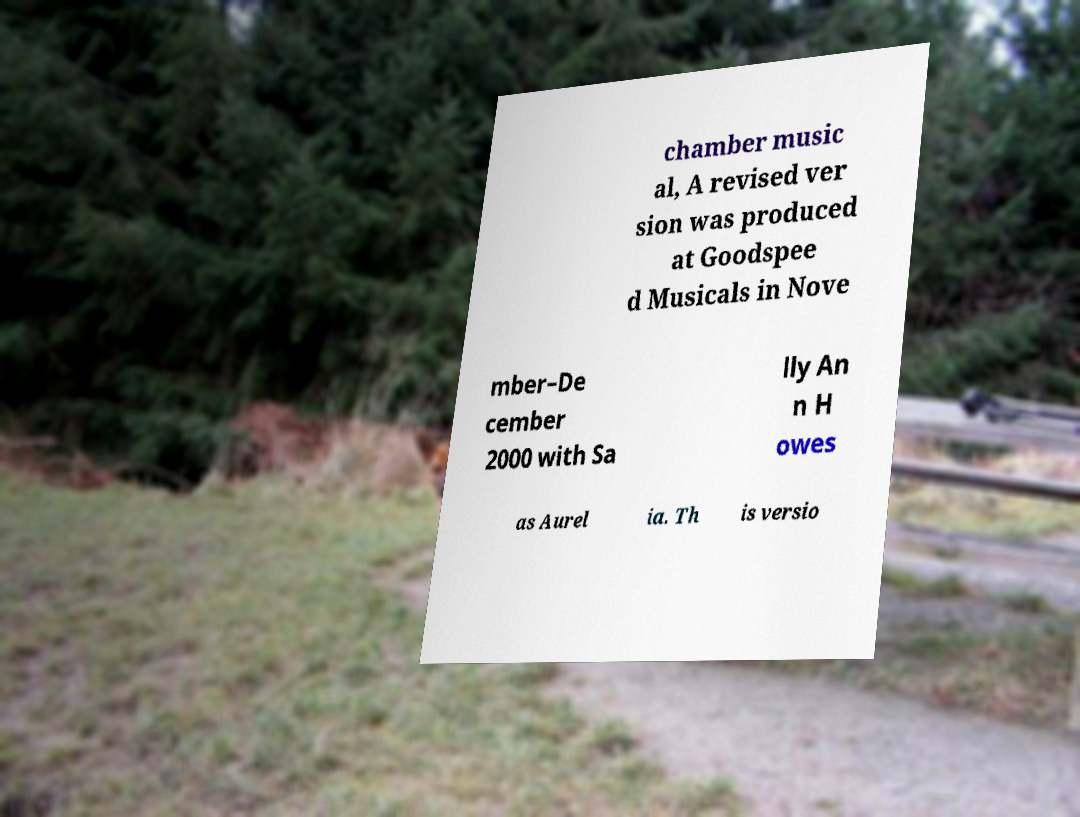Can you read and provide the text displayed in the image?This photo seems to have some interesting text. Can you extract and type it out for me? chamber music al, A revised ver sion was produced at Goodspee d Musicals in Nove mber–De cember 2000 with Sa lly An n H owes as Aurel ia. Th is versio 